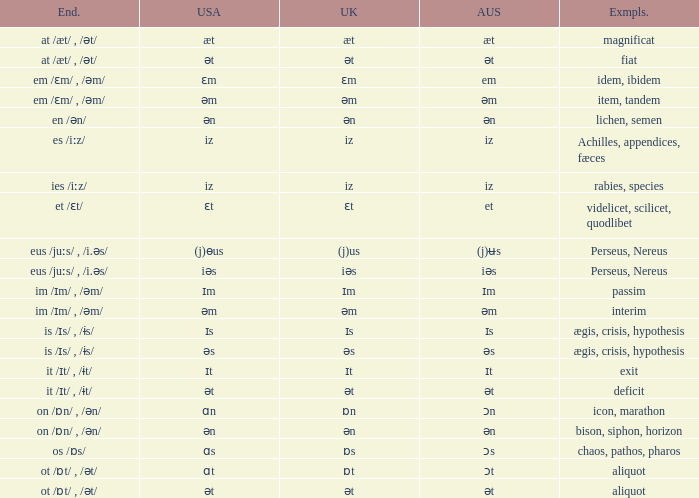Which Australian has British of ɒs? Ɔs. 